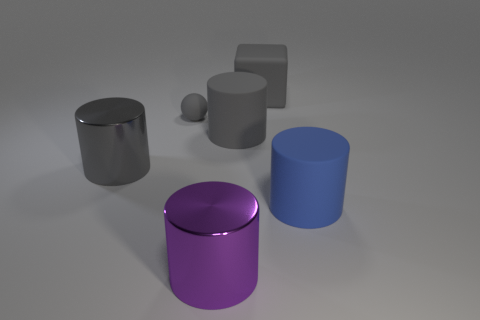Subtract all blue rubber cylinders. How many cylinders are left? 3 Subtract all blue balls. How many gray cylinders are left? 2 Subtract 1 cylinders. How many cylinders are left? 3 Subtract all purple cylinders. How many cylinders are left? 3 Add 2 large matte balls. How many objects exist? 8 Subtract all blue cylinders. Subtract all blue blocks. How many cylinders are left? 3 Subtract all spheres. How many objects are left? 5 Subtract 0 cyan cylinders. How many objects are left? 6 Subtract all small gray balls. Subtract all blue rubber cylinders. How many objects are left? 4 Add 4 large gray matte cylinders. How many large gray matte cylinders are left? 5 